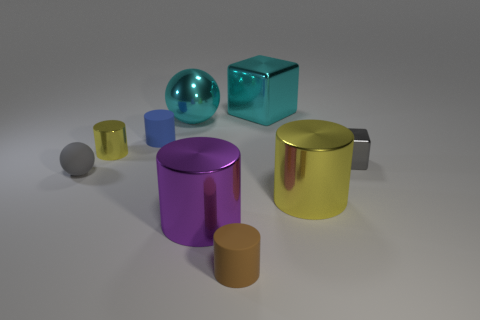There is a object that is the same color as the metallic ball; what is its material?
Your answer should be very brief. Metal. How many other objects are the same color as the big ball?
Offer a very short reply. 1. How many things are either small blue cylinders that are behind the brown rubber cylinder or things in front of the gray cube?
Keep it short and to the point. 5. Are there fewer big objects than large purple metal objects?
Your answer should be compact. No. There is a gray cube; does it have the same size as the metallic thing that is behind the large cyan ball?
Offer a terse response. No. What number of metal things are either yellow blocks or big purple objects?
Your response must be concise. 1. Is the number of shiny balls greater than the number of big red metal things?
Make the answer very short. Yes. What is the size of the sphere that is the same color as the big metallic cube?
Give a very brief answer. Large. What is the shape of the yellow metal thing to the left of the matte cylinder that is on the left side of the brown matte cylinder?
Make the answer very short. Cylinder. There is a matte cylinder that is behind the yellow shiny cylinder in front of the gray sphere; is there a small brown cylinder behind it?
Your response must be concise. No. 